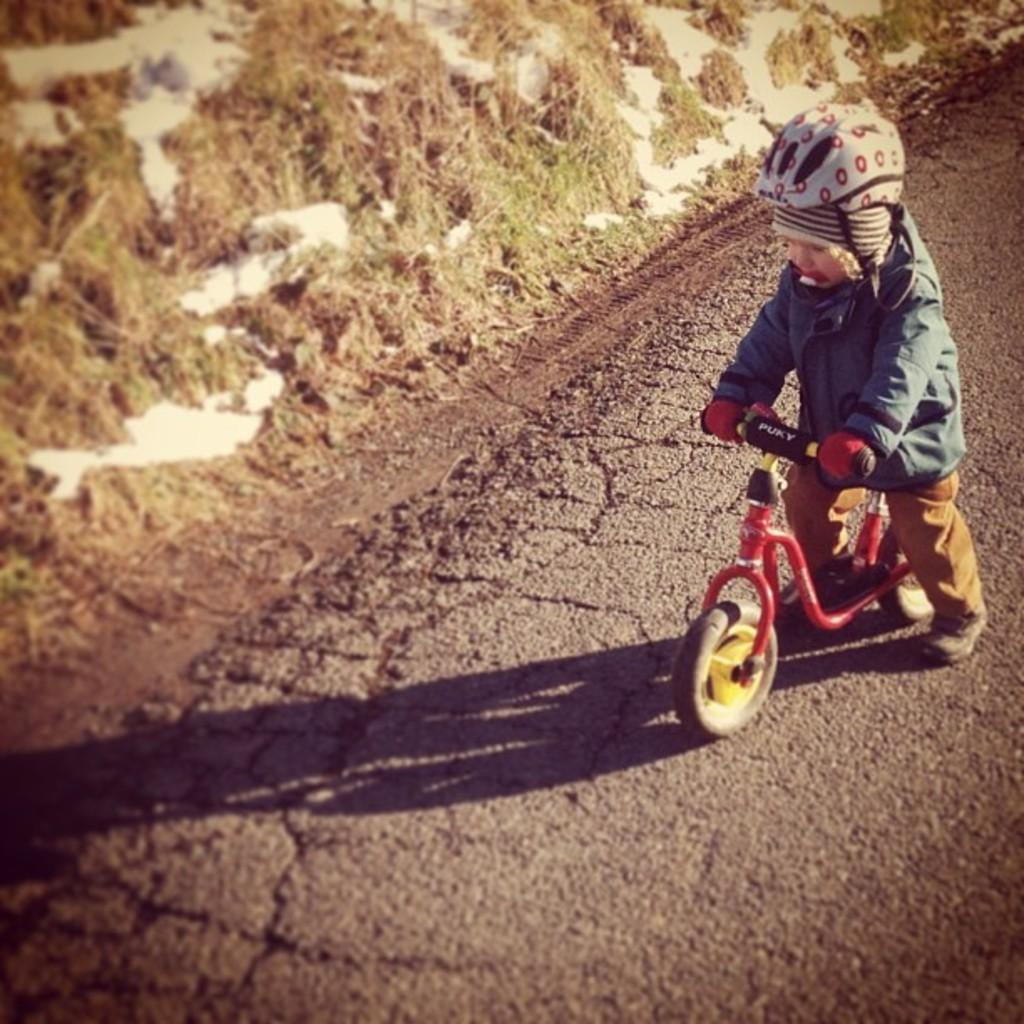What is the main subject of the image? The main subject of the image is a kid. What is the kid doing in the image? The kid is seated on a bicycle. What can be seen in the background of the image? There is grass visible in the background of the image. How many babies are present in the image? There are no babies present in the image; it features a kid seated on a bicycle. What type of army equipment can be seen in the image? There is no army equipment present in the image. 